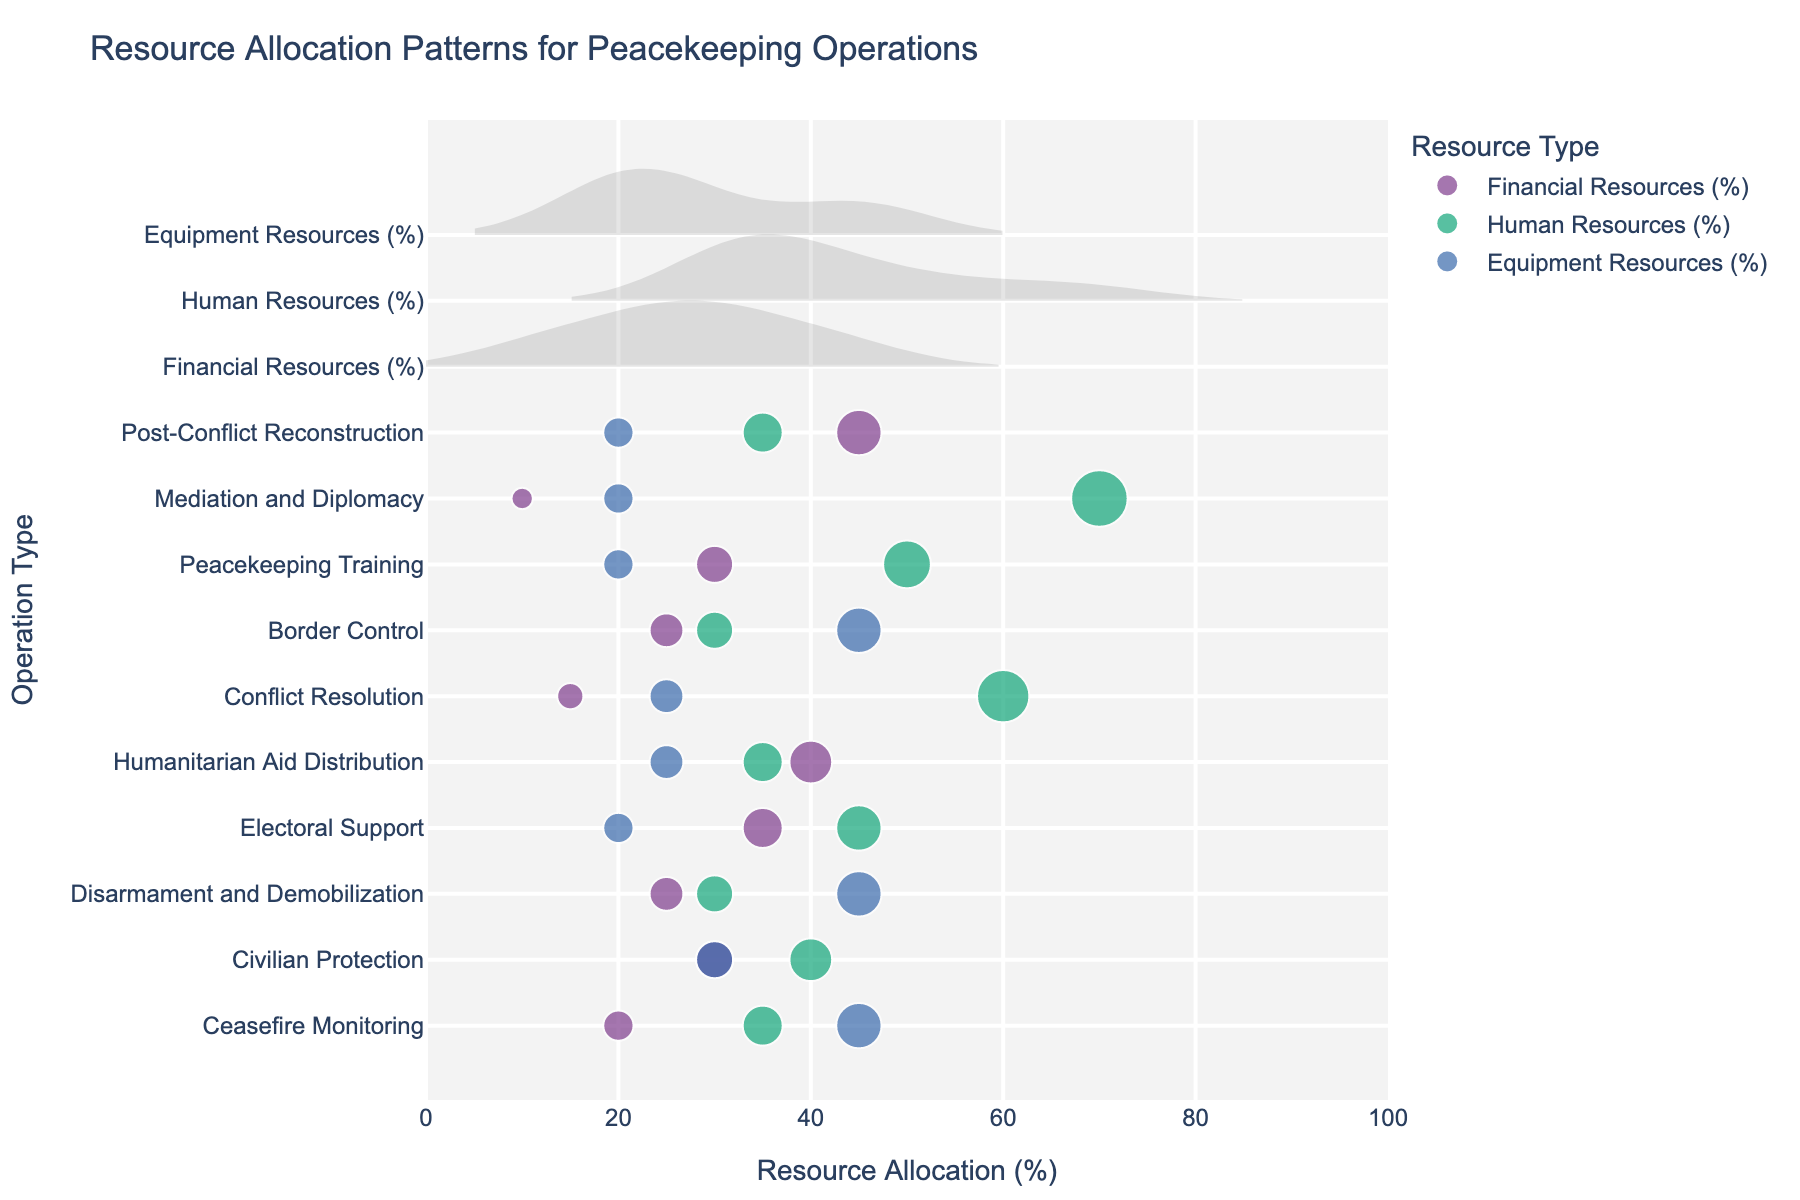What's the title of the figure? The title of the figure can be directly read from the top of the visual.
Answer: Resource Allocation Patterns for Peacekeeping Operations Which peacekeeping operation type has the highest allocation of financial resources? By observing the horizontal density plot, the operation type with the dot furthest to the right for the Financial Resources category has the highest allocation.
Answer: Post-Conflict Reconstruction What is the average percentage allocated to equipment resources across all peacekeeping operation types? To find the average, add the percentages for Equipment Resources for all operation types and then divide by the number of operations. The percentages are 45, 30, 45, 20, 25, 25, 45, 20, 20, 20. Total = 295. The number of operations is 10. So, 295/10 = 29.5.
Answer: 29.5% Which peacekeeping operation types have human resources allocations that are greater than 50%? By looking at the positions of the dots for Human Resources, identify those which are beyond the 50% mark on the x-axis.
Answer: Conflict Resolution, Mediation and Diplomacy What is the difference in financial resources allocation between Humanitarian Aid Distribution and Border Control? To find the difference, subtract the percentage for Border Control from that of Humanitarian Aid Distribution. Humanitarian Aid Distribution: 40%, Border Control: 25%. So, 40% - 25% = 15%.
Answer: 15% Describe the pattern in resource allocation for the Mediation and Diplomacy operation type. This operation type has three different allocations: Financial Resources, Human Resources, and Equipment Resources. Mediation and Diplomacy has 10% for Financial Resources, 70% for Human Resources, and 20% for Equipment Resources.
Answer: Financial: 10%, Human: 70%, Equipment: 20% Which operation type has the most equal distribution of resources across the three types? By observing the plot, the operation type with dots closest together horizontally for all resource types indicates the most equal distribution.
Answer: Civilian Protection How many peacekeeping operation types allocate more than 30% to financial resources? Count the number of operation types with their Financial Resources allocation dots placed beyond the 30% mark on the x-axis.
Answer: Four Compare the human resources allocation for Ceasefire Monitoring and Post-Conflict Reconstruction. Which one is higher? Identify and compare the positions of the dots for Human Resources allocations for both operation types. Ceasefire Monitoring has 35%, while Post-Conflict Reconstruction has 35%. Neither is higher since both are equal.
Answer: Neither (both at 35%) For Peacekeeping Training, what is the sum of the allocations for financial and equipment resources? Add the percentages for Financial Resources and Equipment Resources for Peacekeeping Training. Financial: 30%, Equipment: 20%. So, 30% + 20% = 50%.
Answer: 50% 